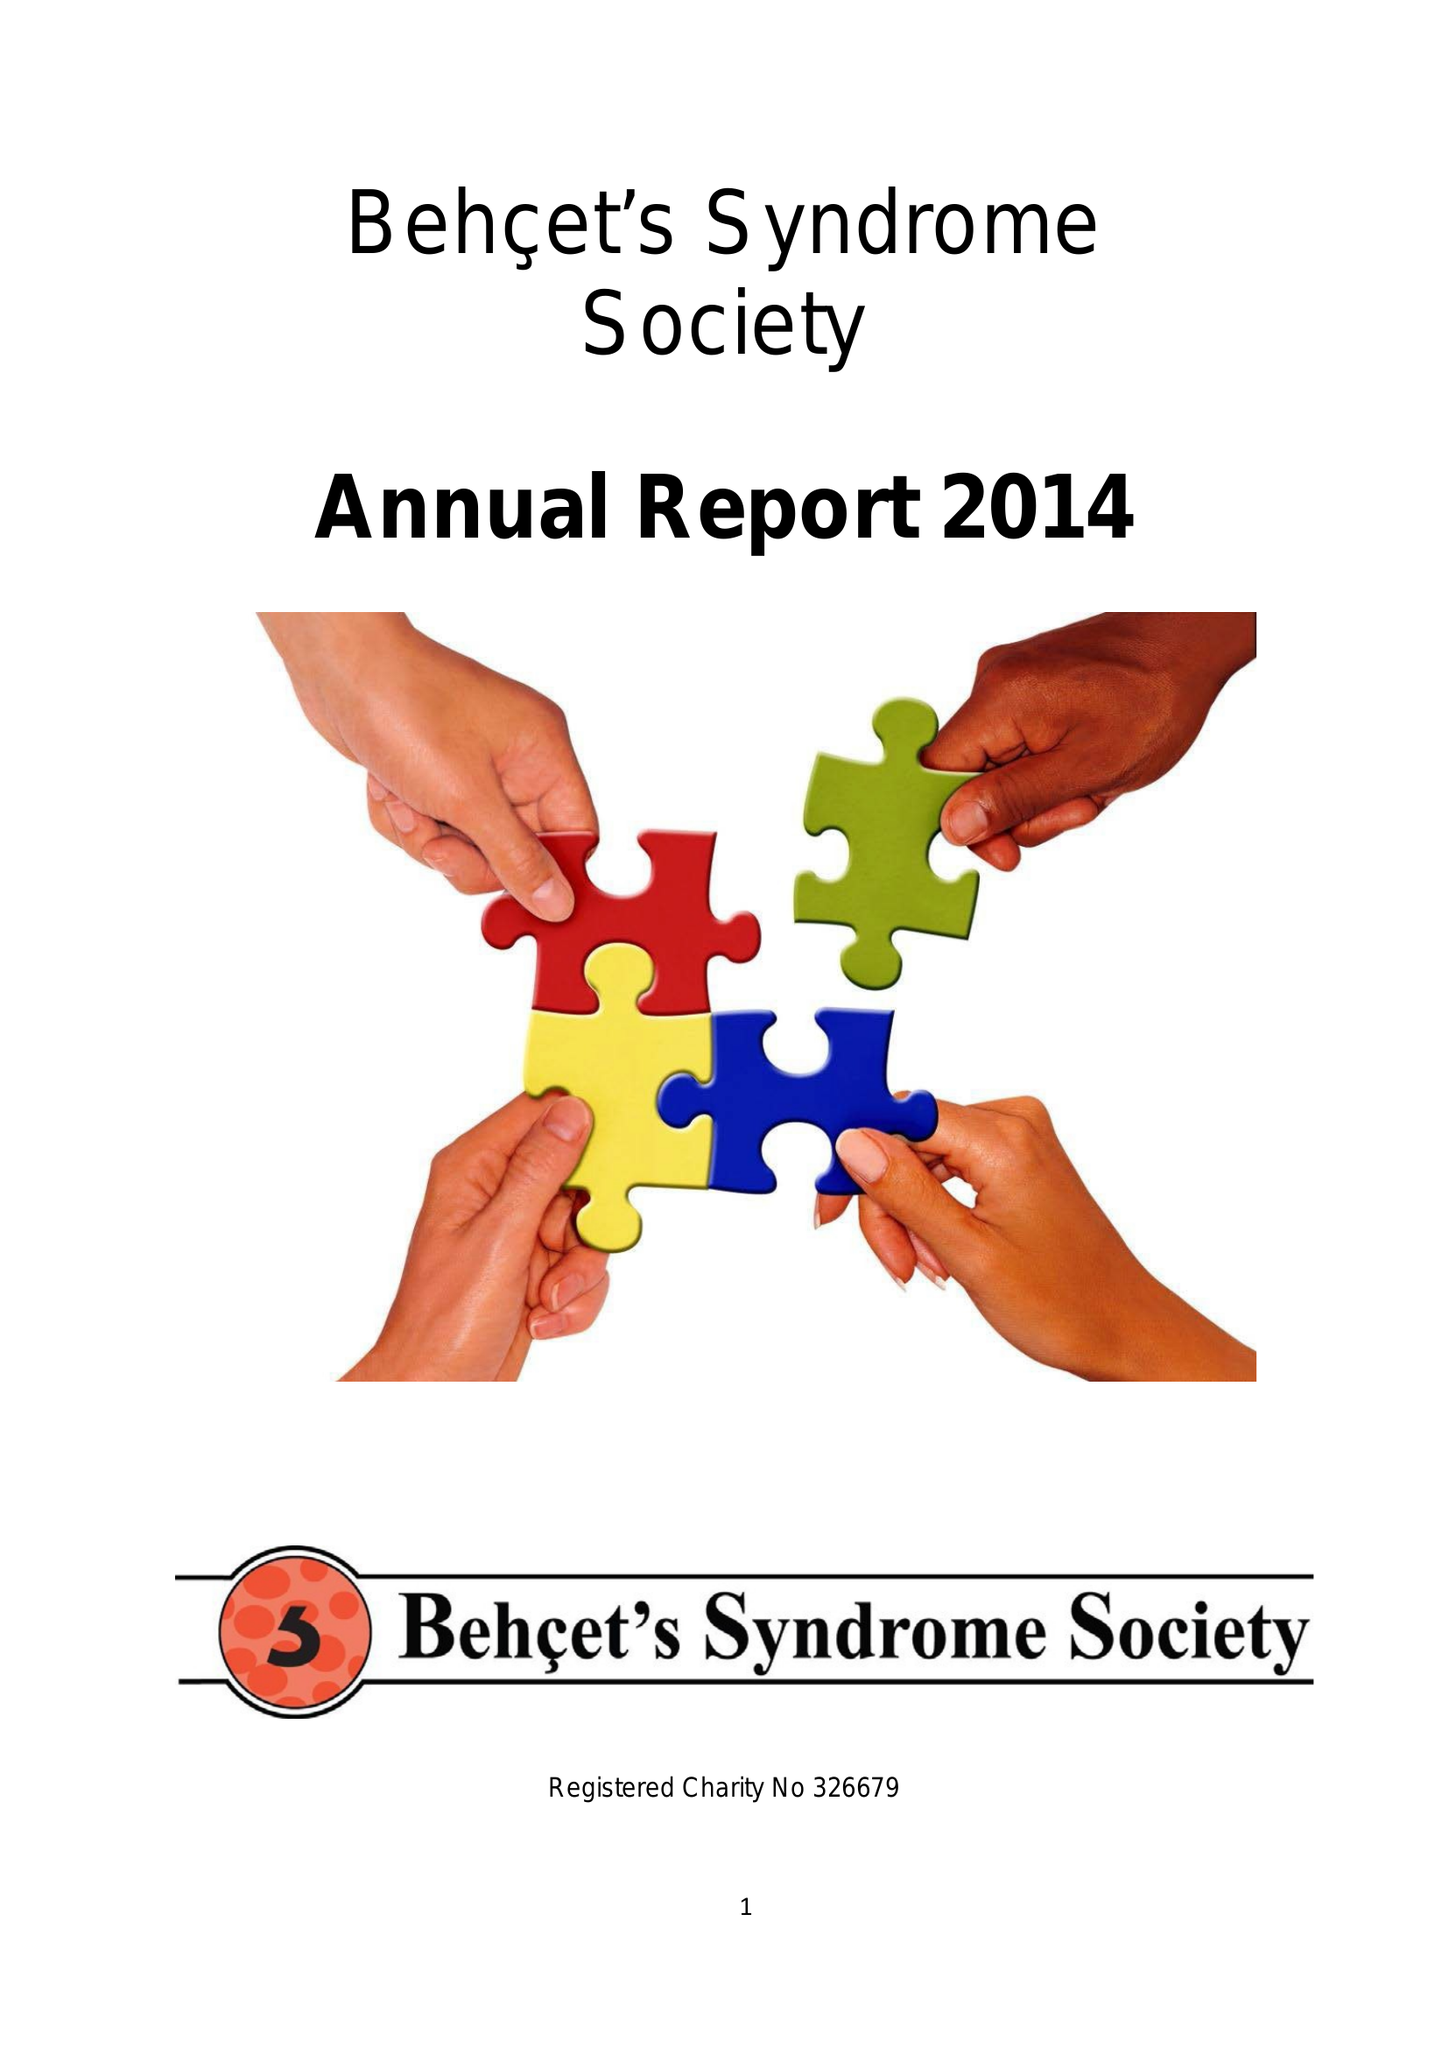What is the value for the income_annually_in_british_pounds?
Answer the question using a single word or phrase. 88082.00 